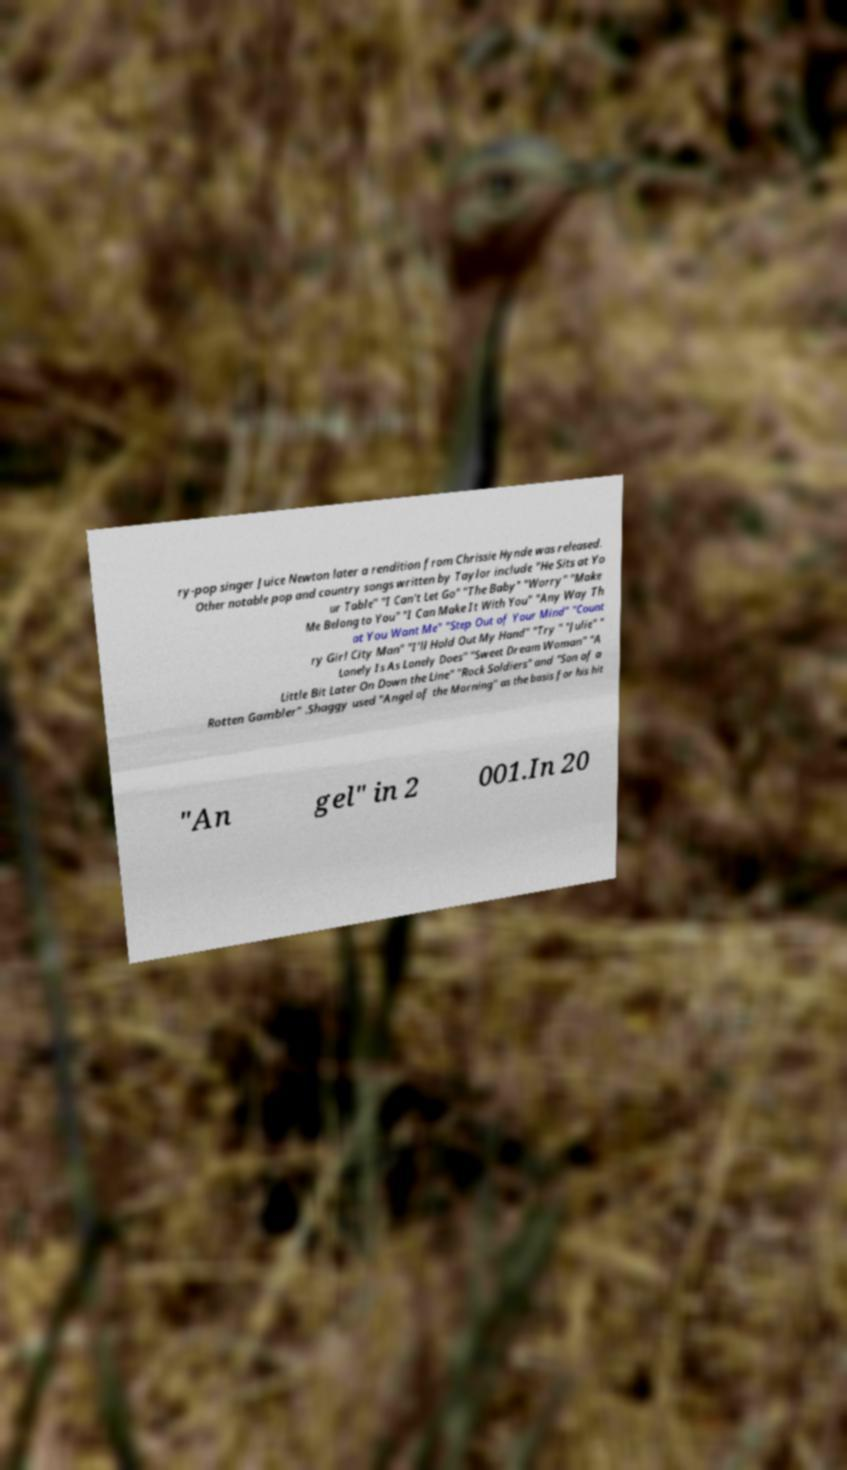There's text embedded in this image that I need extracted. Can you transcribe it verbatim? ry-pop singer Juice Newton later a rendition from Chrissie Hynde was released. Other notable pop and country songs written by Taylor include "He Sits at Yo ur Table" "I Can't Let Go" "The Baby" "Worry" "Make Me Belong to You" "I Can Make It With You" "Any Way Th at You Want Me" "Step Out of Your Mind" "Count ry Girl City Man" "I'll Hold Out My Hand" "Try " "Julie" " Lonely Is As Lonely Does" "Sweet Dream Woman" "A Little Bit Later On Down the Line" "Rock Soldiers" and "Son of a Rotten Gambler" .Shaggy used "Angel of the Morning" as the basis for his hit "An gel" in 2 001.In 20 